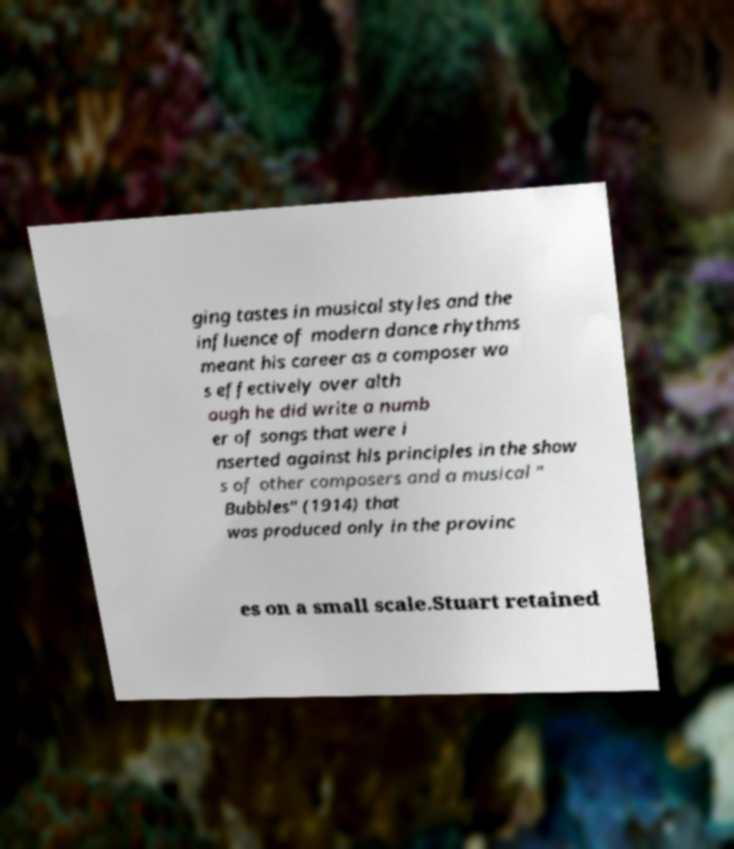Could you extract and type out the text from this image? ging tastes in musical styles and the influence of modern dance rhythms meant his career as a composer wa s effectively over alth ough he did write a numb er of songs that were i nserted against his principles in the show s of other composers and a musical " Bubbles" (1914) that was produced only in the provinc es on a small scale.Stuart retained 